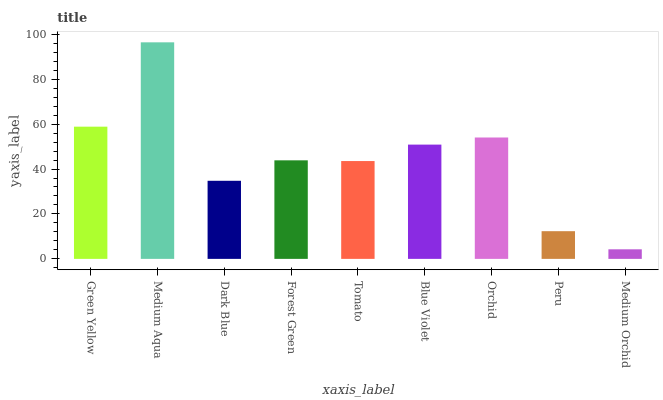Is Medium Orchid the minimum?
Answer yes or no. Yes. Is Medium Aqua the maximum?
Answer yes or no. Yes. Is Dark Blue the minimum?
Answer yes or no. No. Is Dark Blue the maximum?
Answer yes or no. No. Is Medium Aqua greater than Dark Blue?
Answer yes or no. Yes. Is Dark Blue less than Medium Aqua?
Answer yes or no. Yes. Is Dark Blue greater than Medium Aqua?
Answer yes or no. No. Is Medium Aqua less than Dark Blue?
Answer yes or no. No. Is Forest Green the high median?
Answer yes or no. Yes. Is Forest Green the low median?
Answer yes or no. Yes. Is Orchid the high median?
Answer yes or no. No. Is Medium Aqua the low median?
Answer yes or no. No. 